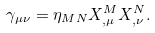<formula> <loc_0><loc_0><loc_500><loc_500>\gamma _ { \mu \nu } = \eta _ { M N } X ^ { M } _ { , \mu } X ^ { N } _ { , \nu } .</formula> 